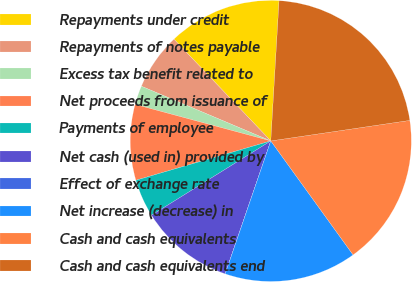Convert chart. <chart><loc_0><loc_0><loc_500><loc_500><pie_chart><fcel>Repayments under credit<fcel>Repayments of notes payable<fcel>Excess tax benefit related to<fcel>Net proceeds from issuance of<fcel>Payments of employee<fcel>Net cash (used in) provided by<fcel>Effect of exchange rate<fcel>Net increase (decrease) in<fcel>Cash and cash equivalents<fcel>Cash and cash equivalents end<nl><fcel>13.04%<fcel>6.53%<fcel>2.18%<fcel>8.7%<fcel>4.35%<fcel>10.87%<fcel>0.01%<fcel>15.21%<fcel>17.38%<fcel>21.73%<nl></chart> 